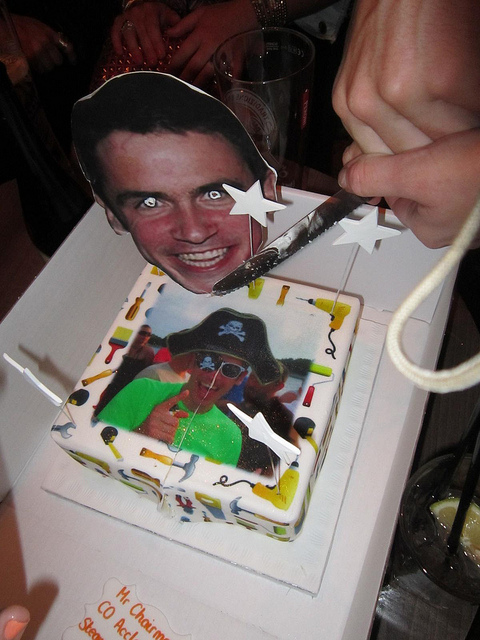Please transcribe the text in this image. Mr CO 